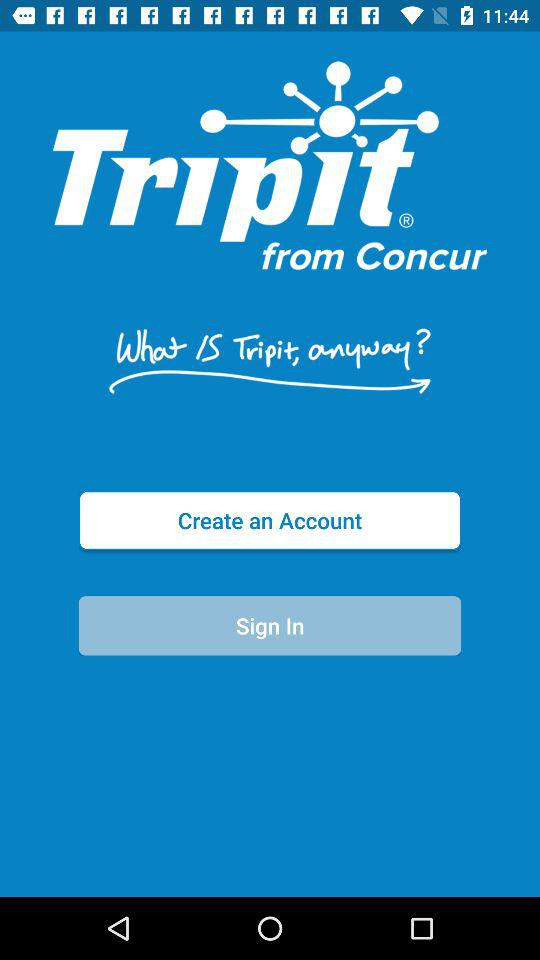What is the app name? The app name is "Tripit". 